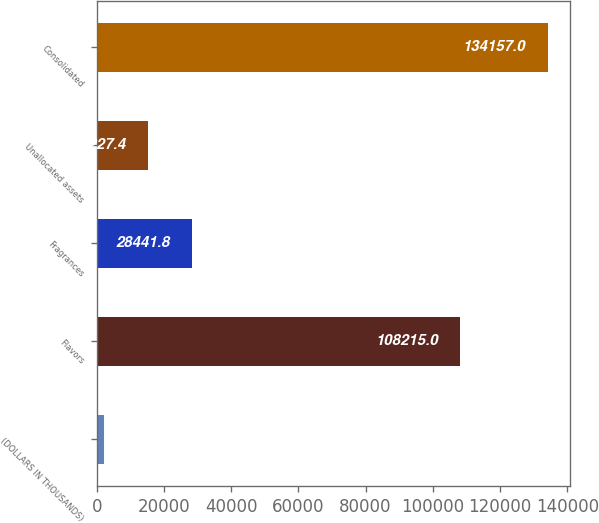<chart> <loc_0><loc_0><loc_500><loc_500><bar_chart><fcel>(DOLLARS IN THOUSANDS)<fcel>Flavors<fcel>Fragrances<fcel>Unallocated assets<fcel>Consolidated<nl><fcel>2013<fcel>108215<fcel>28441.8<fcel>15227.4<fcel>134157<nl></chart> 